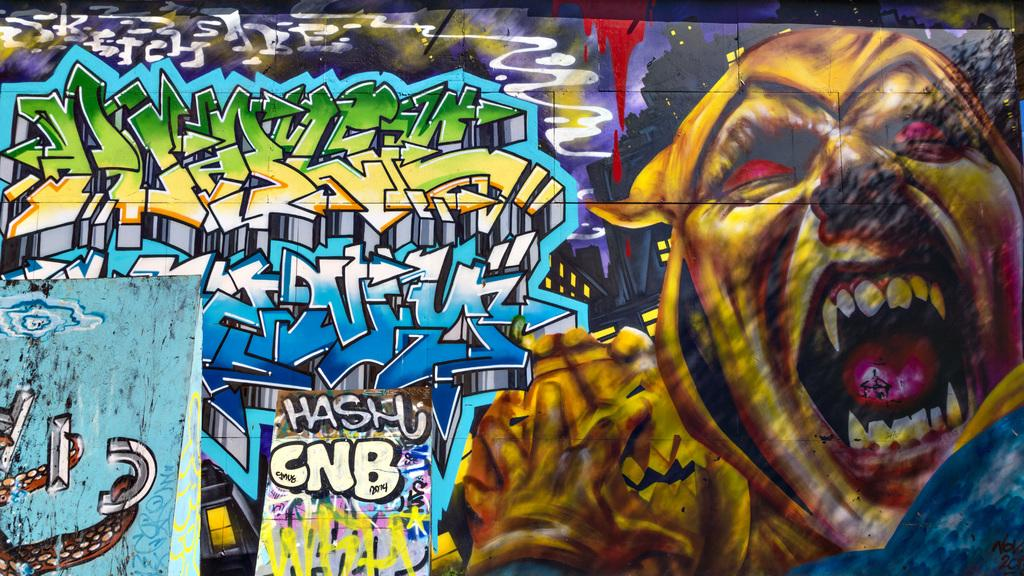What is present on the wall in the image? There is graffiti on the wall in the image. What elements are included in the graffiti? The graffiti includes text and cartoon pictures. How many pins are visible on the wall in the image? There are no pins visible on the wall in the image. What type of bedding is present in the image? There is no bedding present in the image; it features graffiti on a wall. 